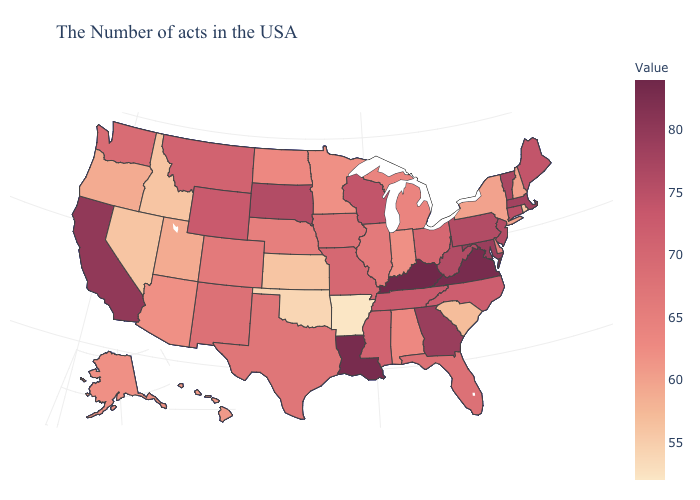Does Kentucky have the highest value in the USA?
Quick response, please. Yes. Which states hav the highest value in the MidWest?
Answer briefly. South Dakota. Is the legend a continuous bar?
Write a very short answer. Yes. Among the states that border North Carolina , which have the lowest value?
Give a very brief answer. South Carolina. Does the map have missing data?
Short answer required. No. 